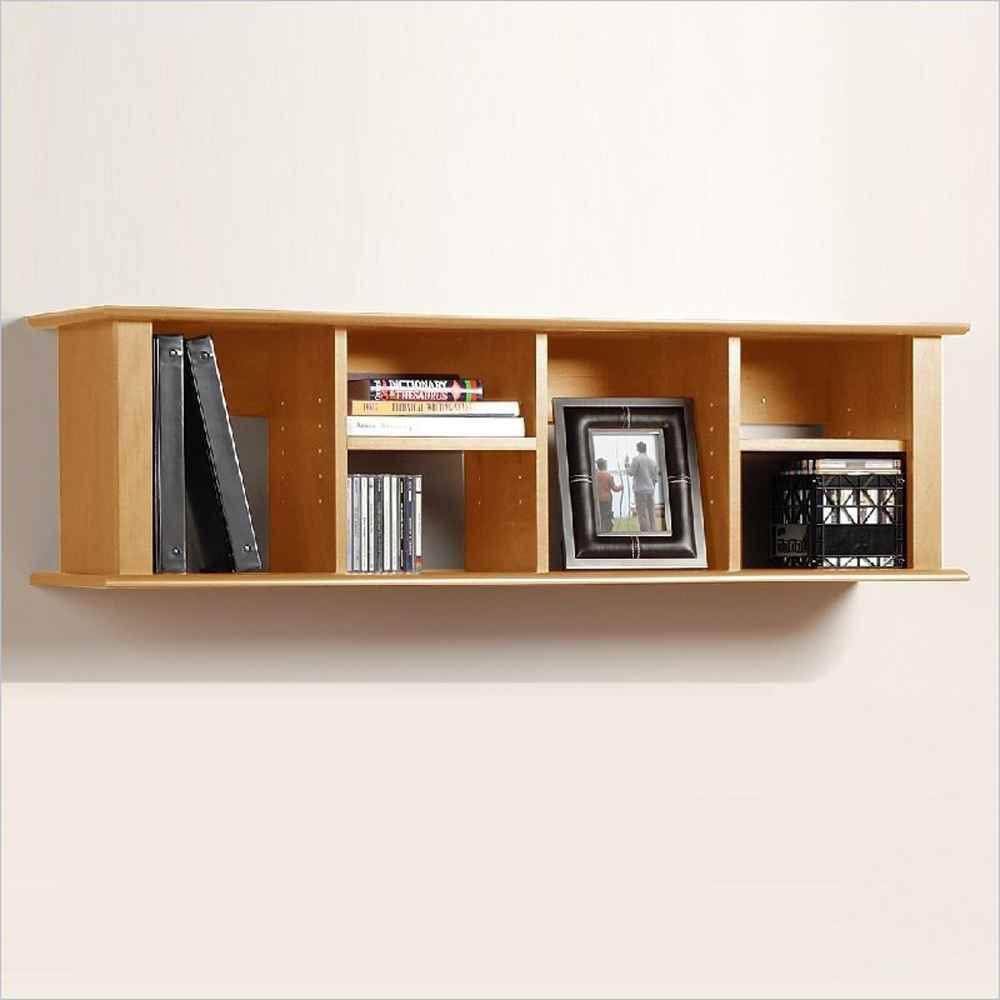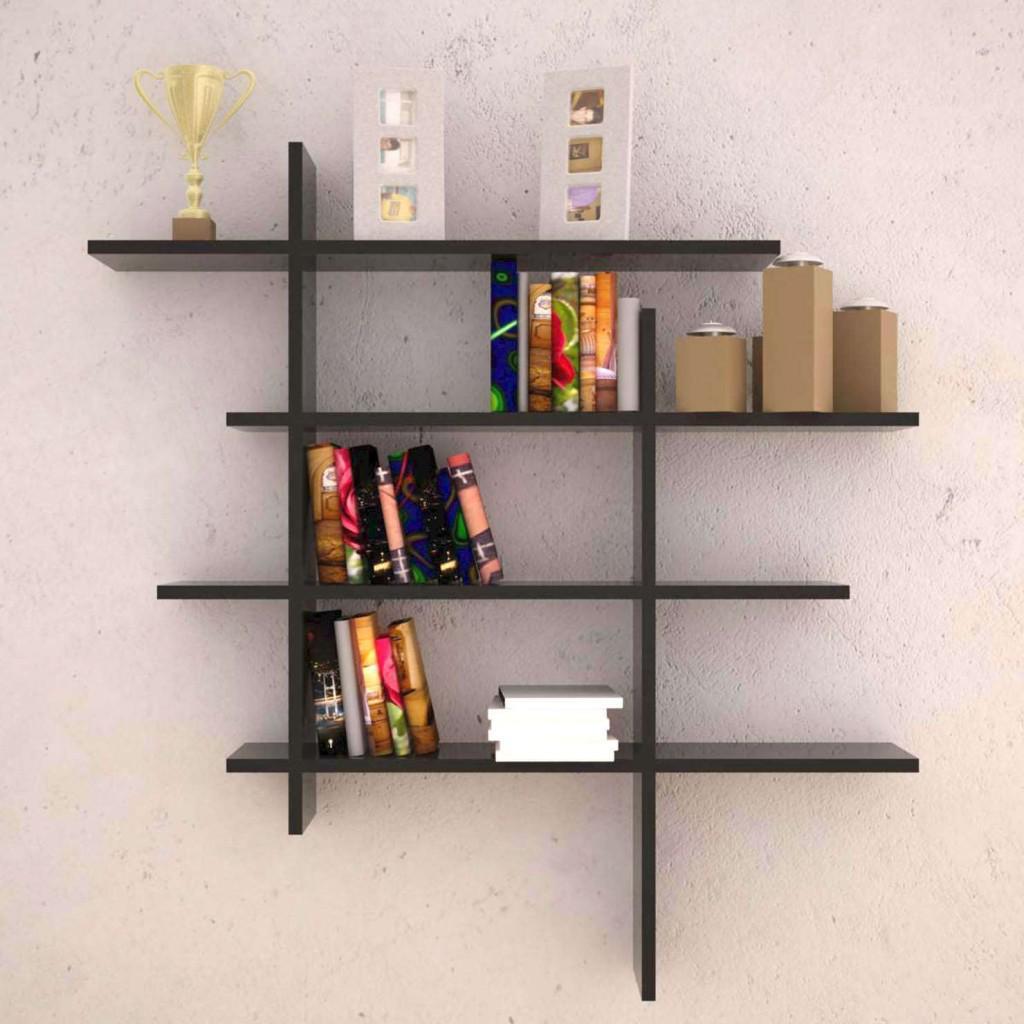The first image is the image on the left, the second image is the image on the right. Examine the images to the left and right. Is the description "The shelf in one of the images is completely black." accurate? Answer yes or no. Yes. The first image is the image on the left, the second image is the image on the right. Analyze the images presented: Is the assertion "Each shelf unit holds some type of items, and one of the units has a single horizontal shelf." valid? Answer yes or no. Yes. 